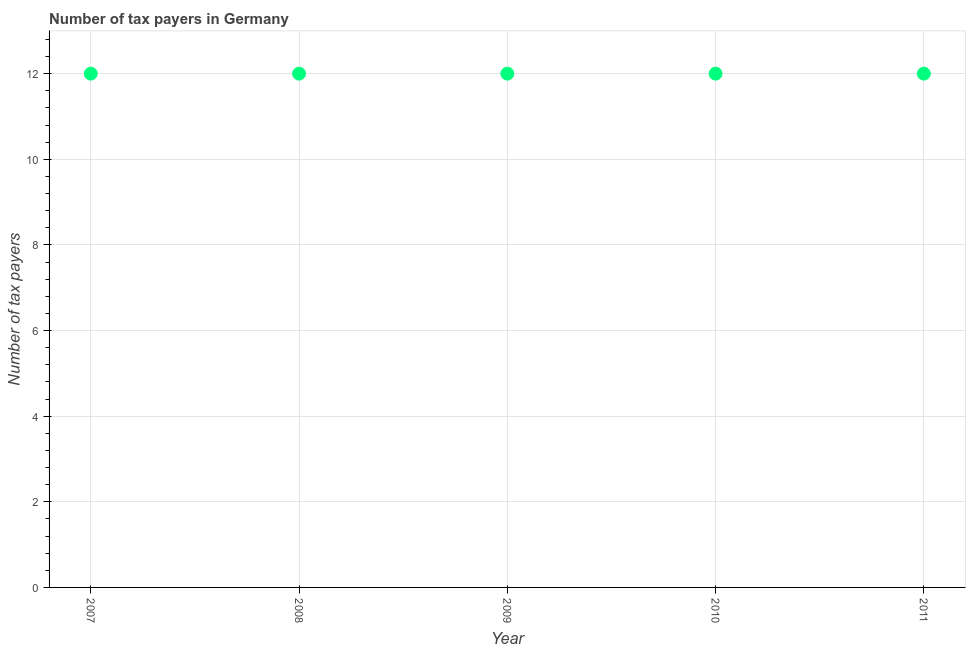What is the number of tax payers in 2011?
Make the answer very short. 12. Across all years, what is the maximum number of tax payers?
Ensure brevity in your answer.  12. Across all years, what is the minimum number of tax payers?
Keep it short and to the point. 12. What is the sum of the number of tax payers?
Give a very brief answer. 60. Do a majority of the years between 2007 and 2008 (inclusive) have number of tax payers greater than 4 ?
Provide a short and direct response. Yes. In how many years, is the number of tax payers greater than the average number of tax payers taken over all years?
Ensure brevity in your answer.  0. Does the number of tax payers monotonically increase over the years?
Make the answer very short. No. Does the graph contain grids?
Keep it short and to the point. Yes. What is the title of the graph?
Give a very brief answer. Number of tax payers in Germany. What is the label or title of the Y-axis?
Keep it short and to the point. Number of tax payers. What is the Number of tax payers in 2007?
Offer a very short reply. 12. What is the Number of tax payers in 2010?
Ensure brevity in your answer.  12. What is the difference between the Number of tax payers in 2007 and 2009?
Ensure brevity in your answer.  0. What is the difference between the Number of tax payers in 2008 and 2009?
Keep it short and to the point. 0. What is the difference between the Number of tax payers in 2009 and 2010?
Provide a succinct answer. 0. What is the difference between the Number of tax payers in 2009 and 2011?
Offer a terse response. 0. What is the ratio of the Number of tax payers in 2007 to that in 2010?
Your answer should be very brief. 1. What is the ratio of the Number of tax payers in 2008 to that in 2009?
Your response must be concise. 1. What is the ratio of the Number of tax payers in 2008 to that in 2011?
Keep it short and to the point. 1. What is the ratio of the Number of tax payers in 2010 to that in 2011?
Give a very brief answer. 1. 